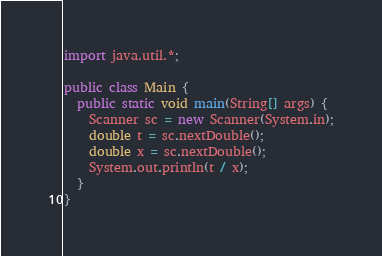Convert code to text. <code><loc_0><loc_0><loc_500><loc_500><_Java_>
import java.util.*;

public class Main {
  public static void main(String[] args) {
    Scanner sc = new Scanner(System.in);
    double t = sc.nextDouble();
    double x = sc.nextDouble();
    System.out.println(t / x);
  }
}</code> 